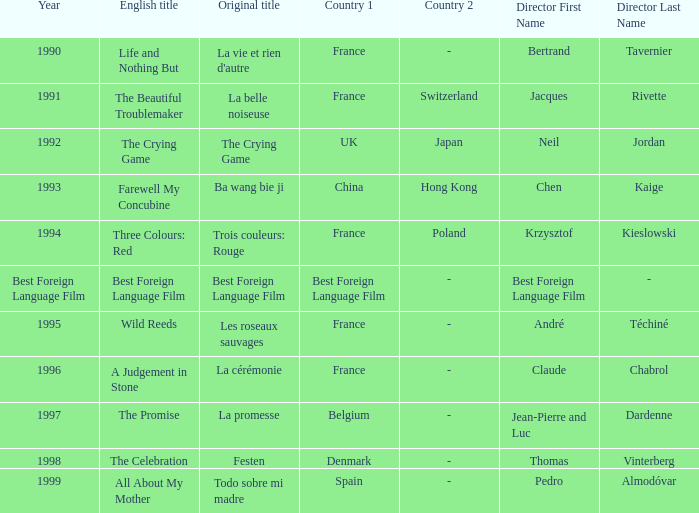What's the Original Title of the English title A Judgement in Stone? La cérémonie. 